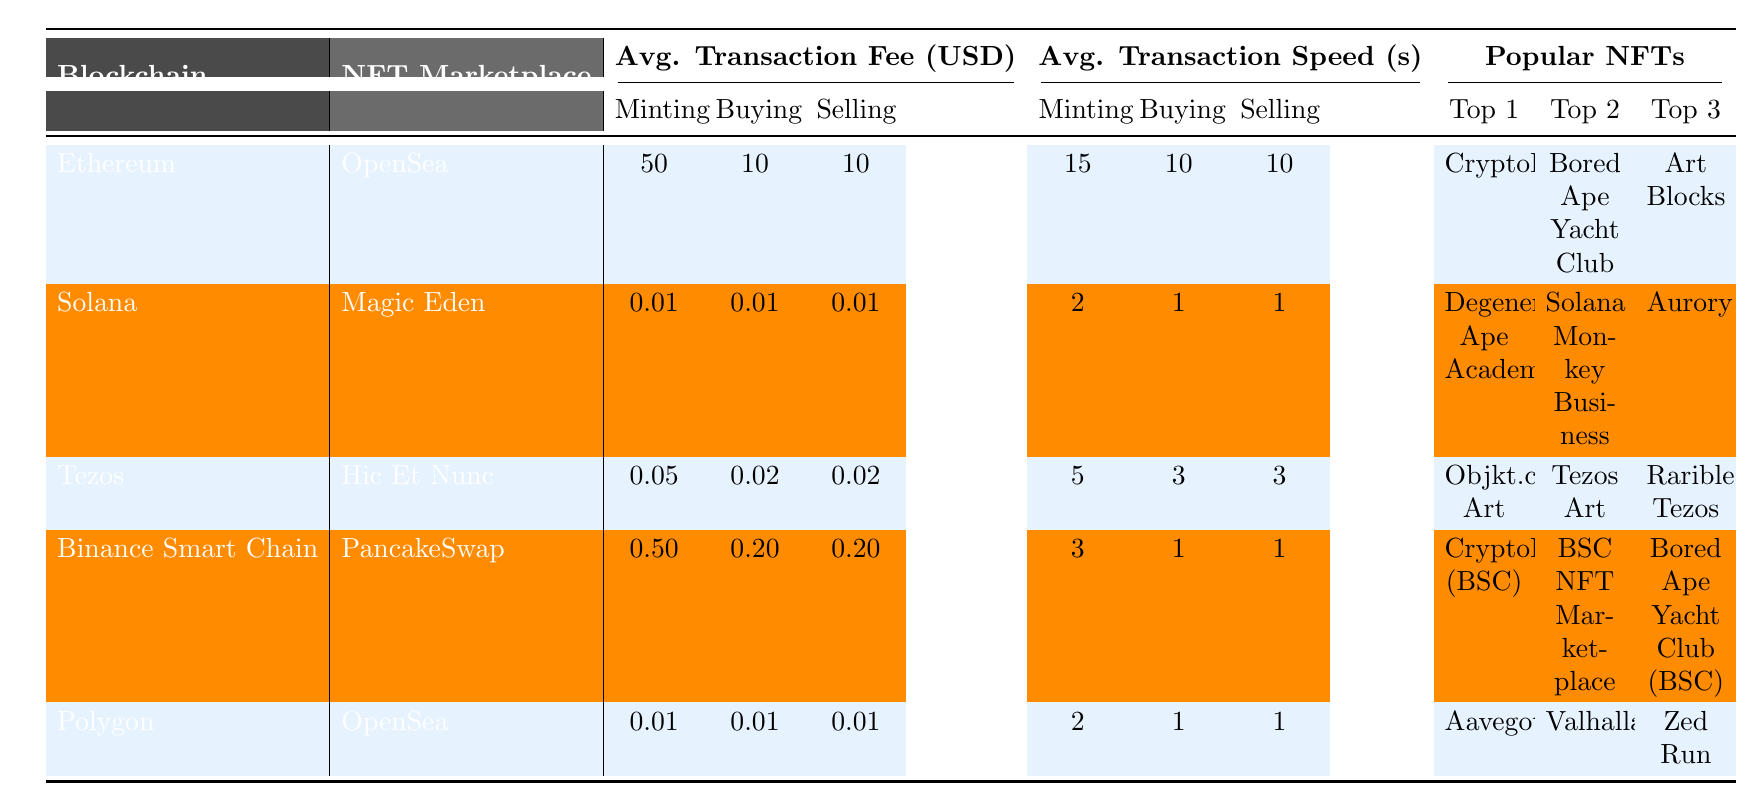What is the average transaction fee for minting on Ethereum? The average transaction fee for minting on Ethereum is stated in the table under "Average Transaction Fee (USD)" for "Minting." It shows a value of 50 USD.
Answer: 50 Which blockchain has the lowest average transaction speed for buying NFTs? To find the lowest average transaction speed for buying NFTs, check the "Average Transaction Speed (seconds)" for "Buying" across all blockchains. Solana has the lowest speed at 1 second, which matches with the values provided for some other blockchains as well.
Answer: 1 How much is the average transaction fee for selling NFTs on Binance Smart Chain? The average transaction fee for selling NFTs on Binance Smart Chain can be found under "Average Transaction Fee (USD)" for "Selling," which shows a value of 0.20 USD.
Answer: 0.20 Which blockchain's average minting fee is greater than the selling fee? Examine the "Average Transaction Fee (USD)" for both "Minting" and "Selling" for each blockchain. Only Ethereum has a minting fee of 50 USD compared to its selling fee of 10 USD, which is greater.
Answer: Ethereum What is the average minting fee across all blockchains? First, sum the minting fees of all blockchains: 50 (Ethereum) + 0.01 (Solana) + 0.05 (Tezos) + 0.50 (Binance Smart Chain) + 0.01 (Polygon) = 50.57 USD. Then divide by the number of blockchains (5), which equals 50.57 / 5 = 10.114 USD.
Answer: 10.114 Is the transaction fee for buying NFTs on Solana higher than that on Tezos? Compare the "Buying" fees for both Solana (0.01 USD) and Tezos (0.02 USD). Since 0.01 is less than 0.02, the statement is false.
Answer: No Which NFT marketplace has the highest average transaction fee for minting? Check the "Average Transaction Fee (USD)" for "Minting" in each row. Ethereum has the highest fee at 50 USD, which is higher than all the other blockchains listed.
Answer: OpenSea (Ethereum) If I were to mint an NFT on each blockchain, what would be the total fee incurred? Add all the minting fees from the blockchains: 50 (Ethereum) + 0.01 (Solana) + 0.05 (Tezos) + 0.50 (Binance Smart Chain) + 0.01 (Polygon) = 50.57 USD.
Answer: 50.57 Which blockchain offers the fastest buying transaction time? Look at the "Average Transaction Speed (seconds)" for "Buying" and identify which blockchain has the lowest number. Both Solana and Polygon have the fastest time at 1 second.
Answer: Solana and Polygon What is the most popular NFT project on Tezos? Under the "Popular NFTs" for Tezos, the top project listed is "Objkt.com Art."
Answer: Objkt.com Art 